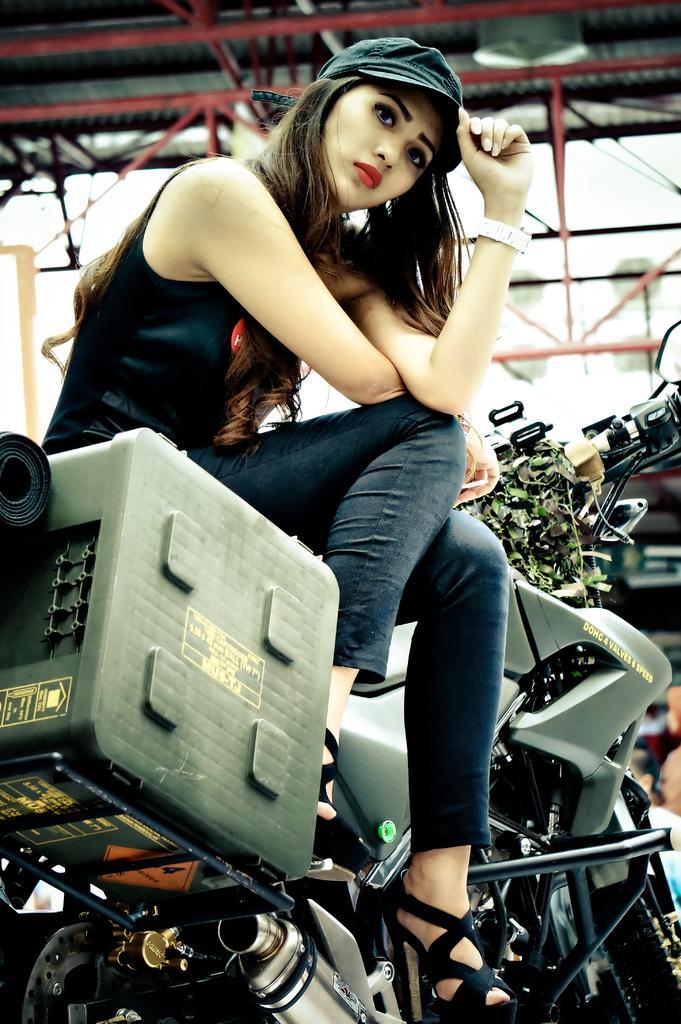In one or two sentences, can you explain what this image depicts? this picture shows a woman seated on the motorcycle and she wore a cap on her head 